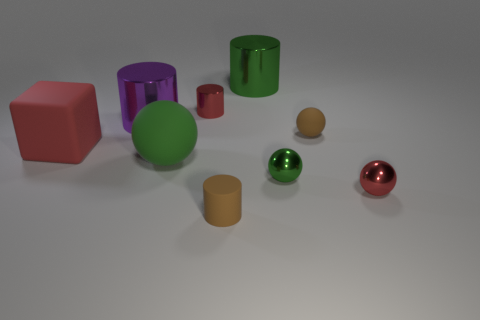Subtract all tiny brown balls. How many balls are left? 3 Subtract 1 cylinders. How many cylinders are left? 3 Subtract all red cylinders. How many cylinders are left? 3 Subtract all cubes. How many objects are left? 8 Subtract all green metallic balls. Subtract all tiny red metallic balls. How many objects are left? 7 Add 3 blocks. How many blocks are left? 4 Add 3 green matte balls. How many green matte balls exist? 4 Subtract 1 red blocks. How many objects are left? 8 Subtract all brown cubes. Subtract all red cylinders. How many cubes are left? 1 Subtract all red cylinders. How many blue blocks are left? 0 